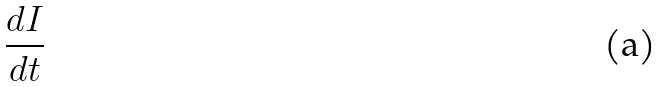<formula> <loc_0><loc_0><loc_500><loc_500>\frac { d I } { d t }</formula> 